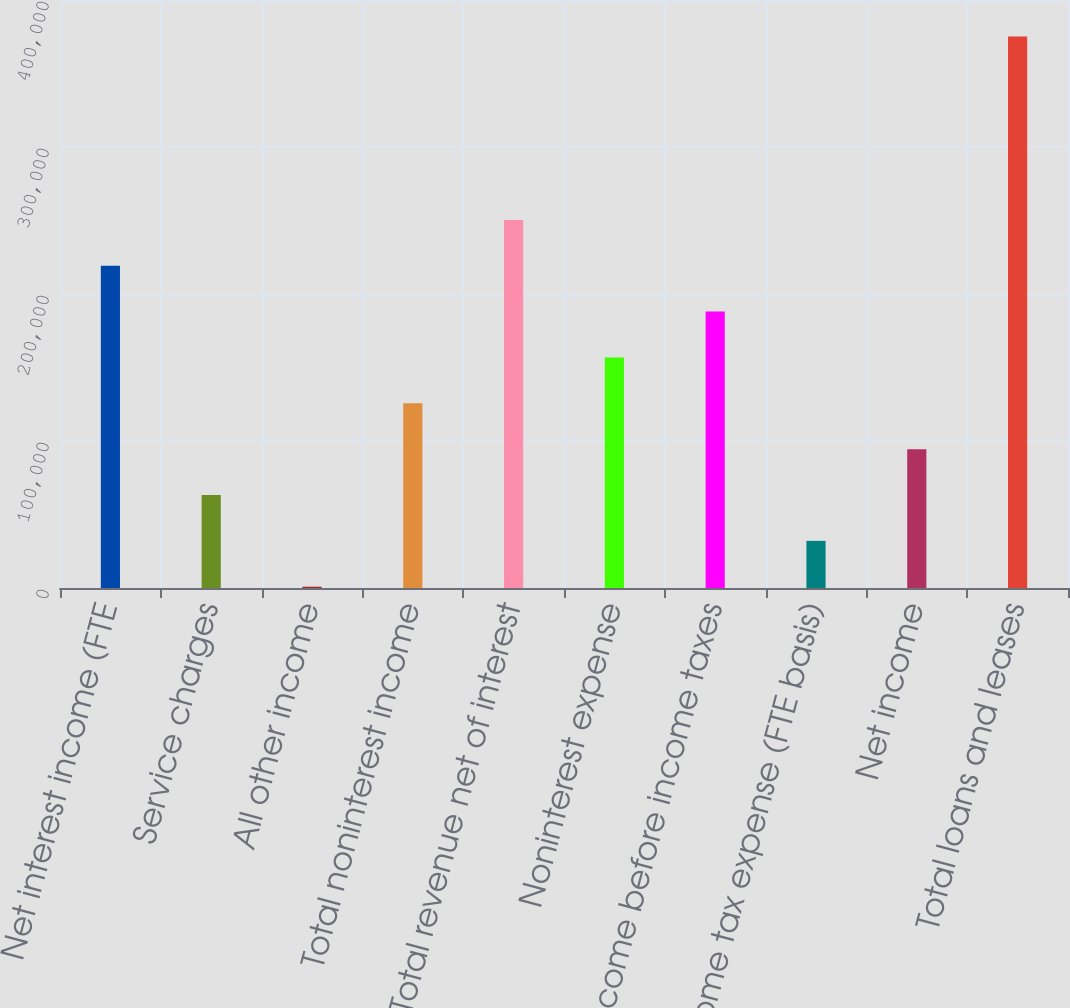Convert chart. <chart><loc_0><loc_0><loc_500><loc_500><bar_chart><fcel>Net interest income (FTE<fcel>Service charges<fcel>All other income<fcel>Total noninterest income<fcel>Total revenue net of interest<fcel>Noninterest expense<fcel>Income before income taxes<fcel>Income tax expense (FTE basis)<fcel>Net income<fcel>Total loans and leases<nl><fcel>219229<fcel>63264.6<fcel>879<fcel>125650<fcel>250421<fcel>156843<fcel>188036<fcel>32071.8<fcel>94457.4<fcel>375193<nl></chart> 